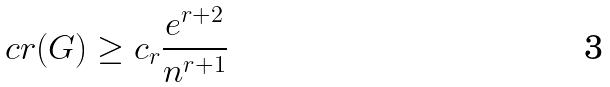<formula> <loc_0><loc_0><loc_500><loc_500>c r ( G ) \geq c _ { r } \frac { e ^ { r + 2 } } { n ^ { r + 1 } }</formula> 